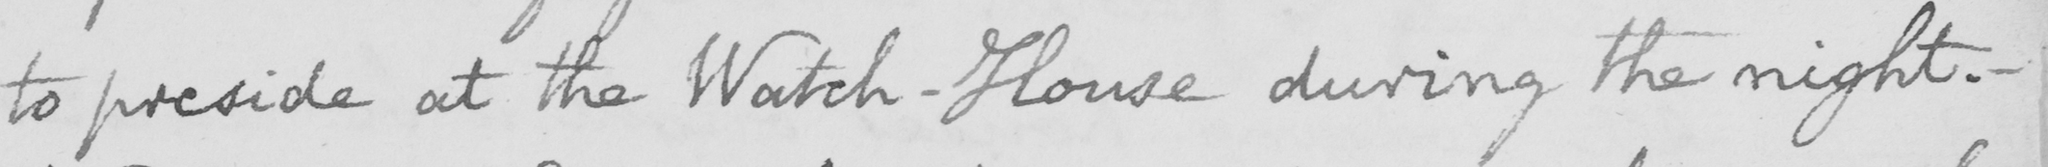Please transcribe the handwritten text in this image. to preside at the Watch-House during the night .  _ 